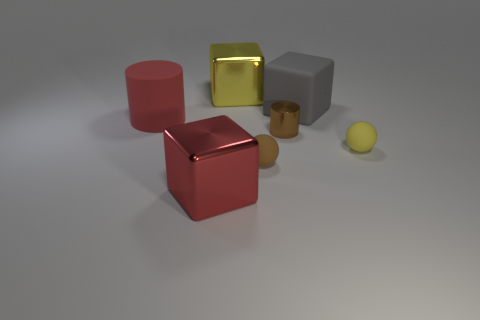There is a big metallic thing that is the same color as the large cylinder; what is its shape?
Offer a very short reply. Cube. The matte thing that is the same shape as the brown metallic object is what color?
Your answer should be very brief. Red. Are there any other things that have the same material as the red cylinder?
Ensure brevity in your answer.  Yes. What size is the red object that is the same shape as the brown metallic thing?
Give a very brief answer. Large. There is a object that is left of the big red shiny cube; what material is it?
Offer a terse response. Rubber. Is the number of small metallic cylinders that are behind the big gray rubber thing less than the number of large red objects?
Your answer should be compact. Yes. There is a yellow thing that is to the right of the large matte thing that is behind the big red rubber cylinder; what is its shape?
Make the answer very short. Sphere. What color is the big matte cylinder?
Offer a terse response. Red. How many other things are the same size as the red matte object?
Provide a succinct answer. 3. What is the material of the large object that is both in front of the gray matte block and right of the big red cylinder?
Your answer should be very brief. Metal. 